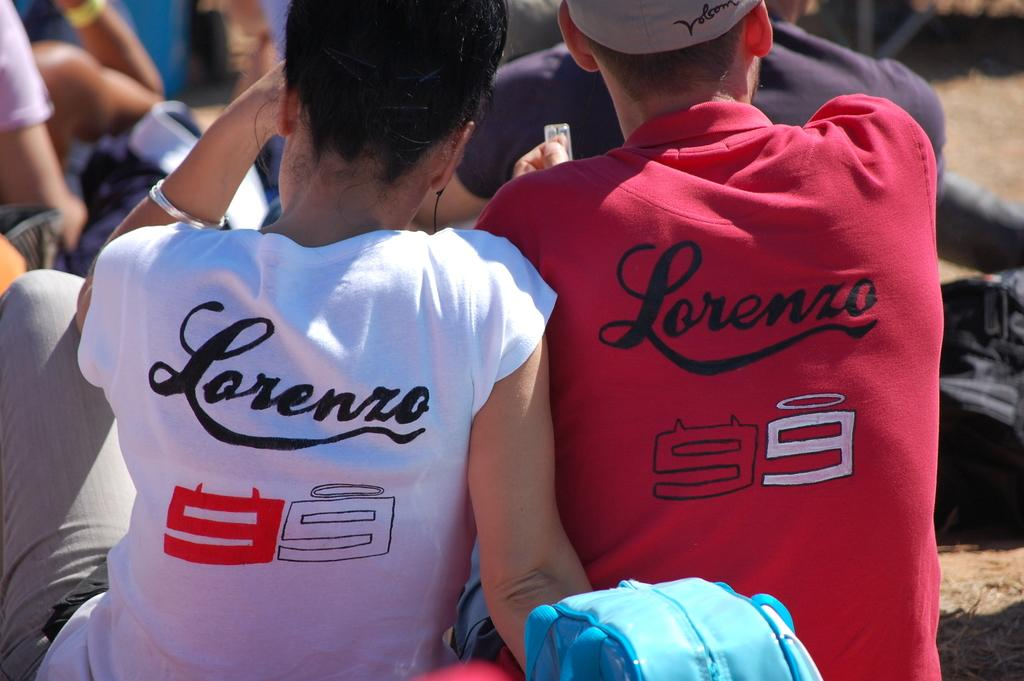<image>
Create a compact narrative representing the image presented. couple wearing lorenzo 99 shirts, hers is white and his is red 